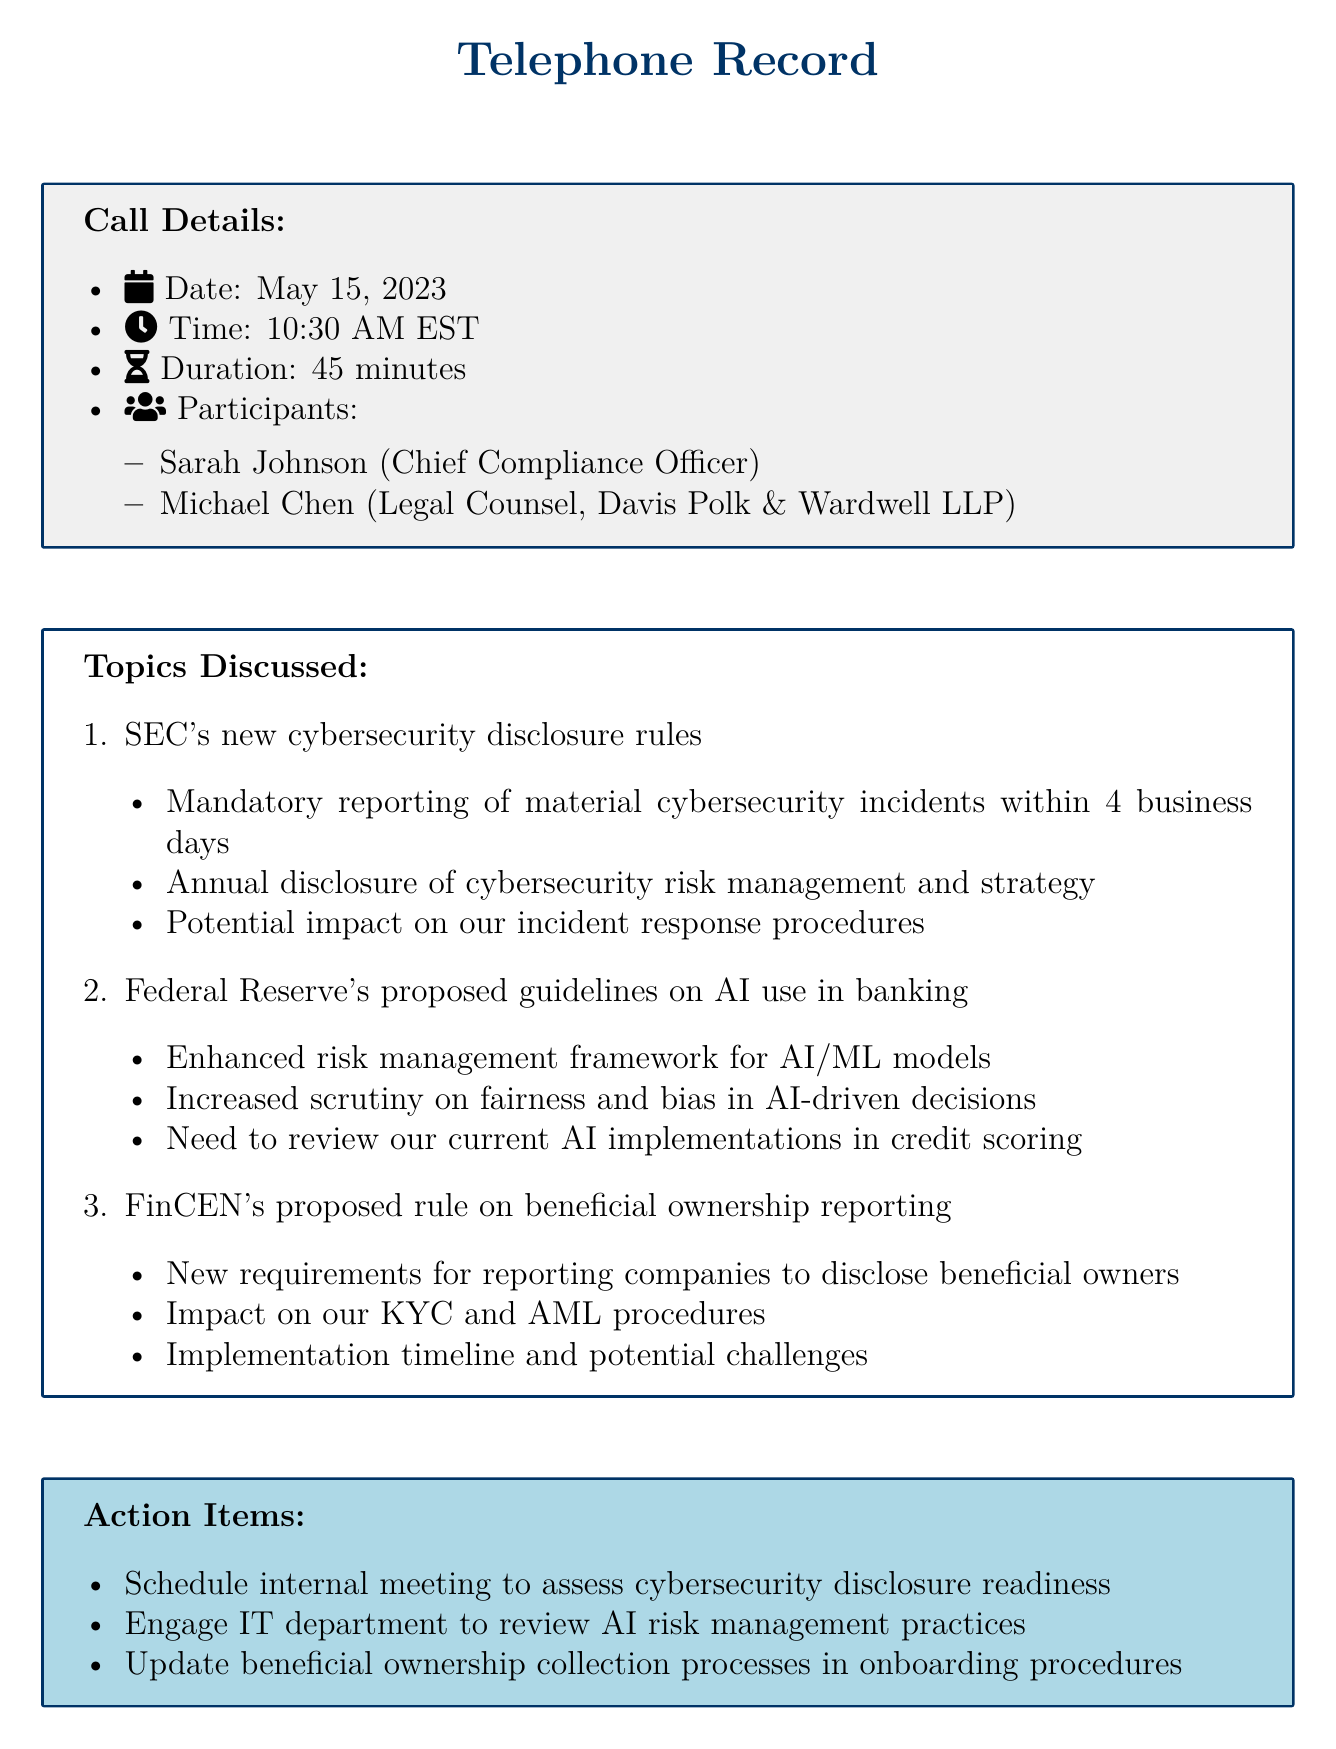What was the date of the call? The date of the call is provided in the call details section of the document.
Answer: May 15, 2023 Who participated in the call? The participants of the call are listed in the call details section.
Answer: Sarah Johnson and Michael Chen What was one of the topics discussed? The document lists multiple topics discussed during the call, particularly regarding financial regulations.
Answer: SEC's new cybersecurity disclosure rules What action item was proposed related to AI? The action items include specific tasks that were discussed during the call regarding the implementation of AI.
Answer: Engage IT department to review AI risk management practices When is the next call scheduled? The document specifies the follow-up information, including the date for the next call.
Answer: June 1, 2023 What new requirement relates to beneficial ownership? The document outlines new requirements that are part of the discussion on beneficial ownership reporting.
Answer: Disclose beneficial owners How long did the call last? The duration of the call is indicated in the call details section of the document.
Answer: 45 minutes What is one potential challenge mentioned for the proposed beneficial ownership rule? The discussion includes potential issues related to implementation timelines for regulatory compliance.
Answer: Potential challenges What is the importance of the SEC's new rules in the context of incident response? The document notes how new regulations can impact the company's current frameworks.
Answer: Impact on our incident response procedures 